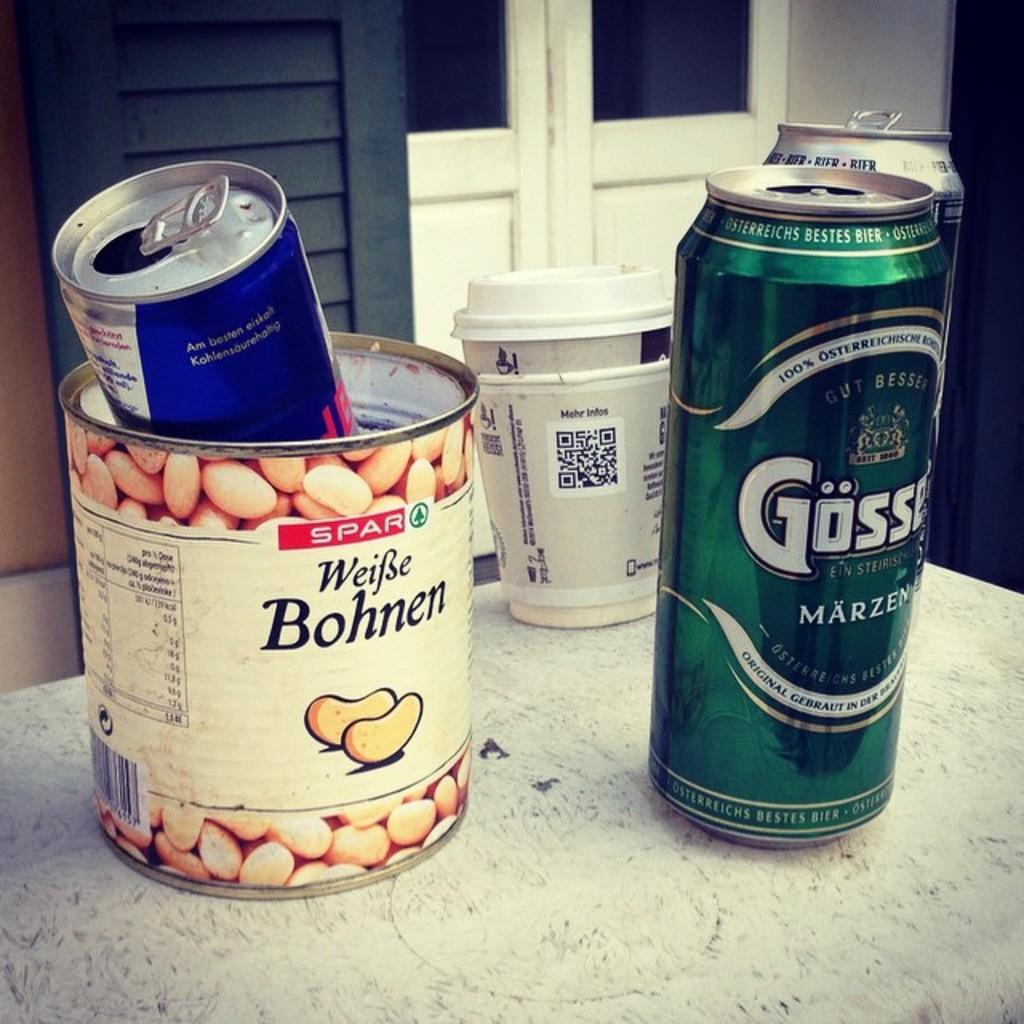<image>
Share a concise interpretation of the image provided. An open and empty can of white beans with the word Bohnen on it has another can set inside of it. 